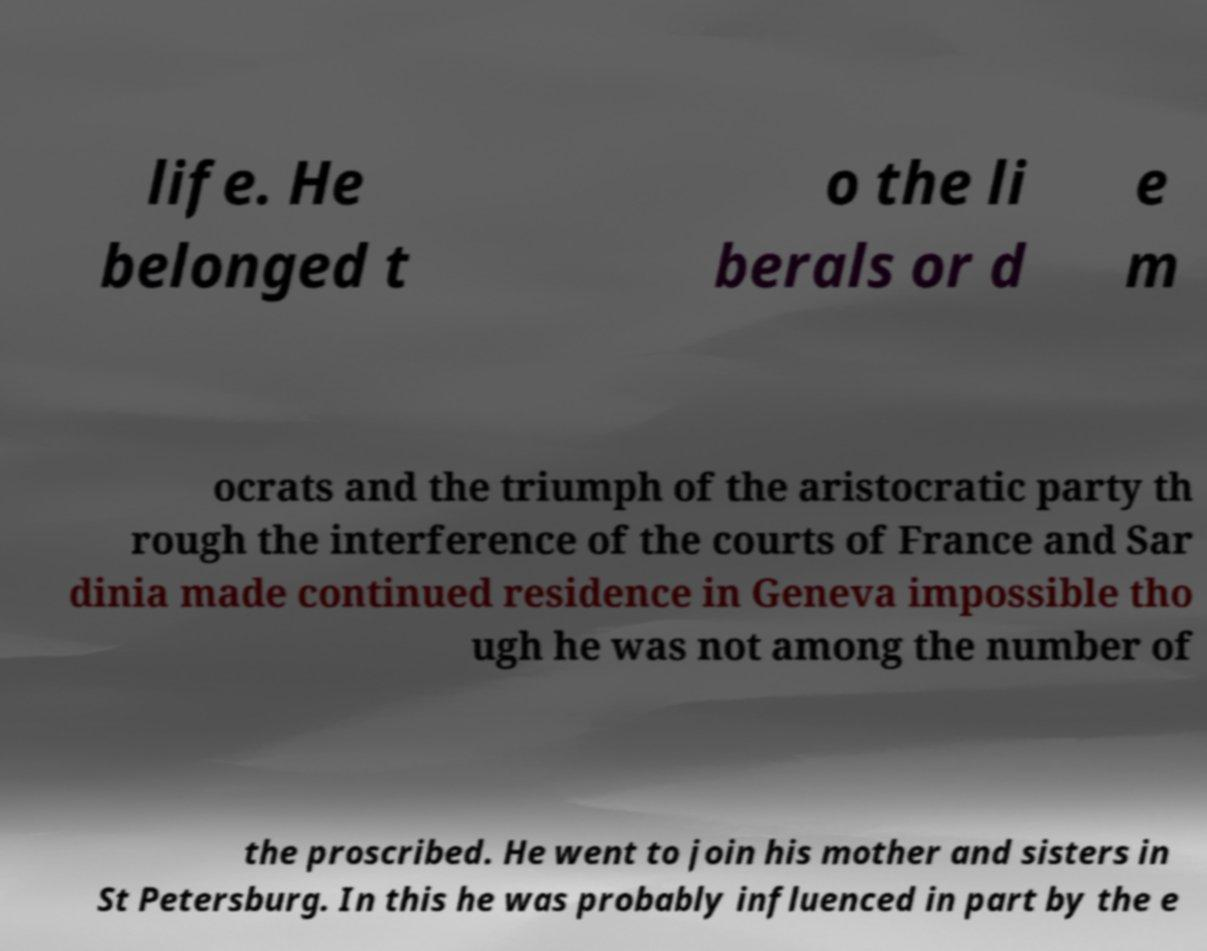Please read and relay the text visible in this image. What does it say? life. He belonged t o the li berals or d e m ocrats and the triumph of the aristocratic party th rough the interference of the courts of France and Sar dinia made continued residence in Geneva impossible tho ugh he was not among the number of the proscribed. He went to join his mother and sisters in St Petersburg. In this he was probably influenced in part by the e 